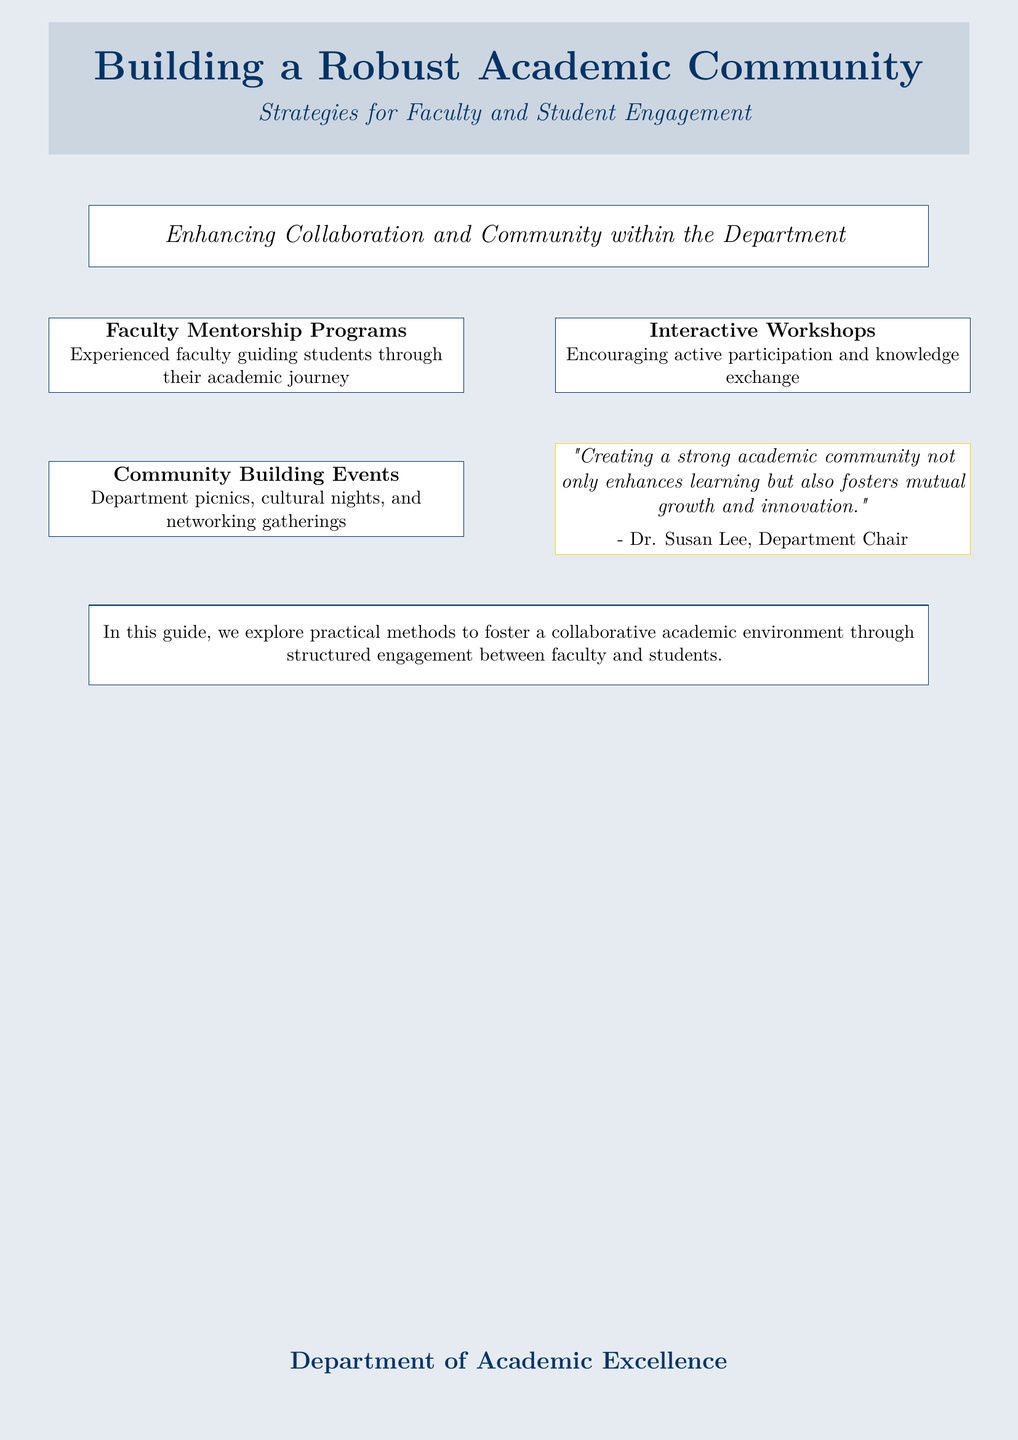What is the title of the book? The title of the book is prominently displayed at the top of the document.
Answer: Building a Robust Academic Community What is the subtitle of the book? The subtitle offers additional context to the title and is found right beneath it.
Answer: Strategies for Faculty and Student Engagement What is one strategy mentioned for faculty engagement? The document lists strategies that enhance engagement between faculty and students, focusing on mentorship.
Answer: Faculty Mentorship Programs What color is emphasized in the design? The cover uses a specific color theme that can be noted in the background and text.
Answer: Academic blue Who is quoted in the document? There is a quote provided that offers insight into the themes of community and innovation, attributed to a specific individual.
Answer: Dr. Susan Lee What type of events are highlighted for community building? The document mentions specific types of gatherings aimed at fostering community interaction within the department.
Answer: Department picnics How many main areas of engagement are mentioned? The document outlines several distinct areas pertaining to faculty and student interaction within the community.
Answer: Three What is the overarching theme of the book? The focus of the content mentioned in the document is central to building an academic environment.
Answer: Collaboration and community 